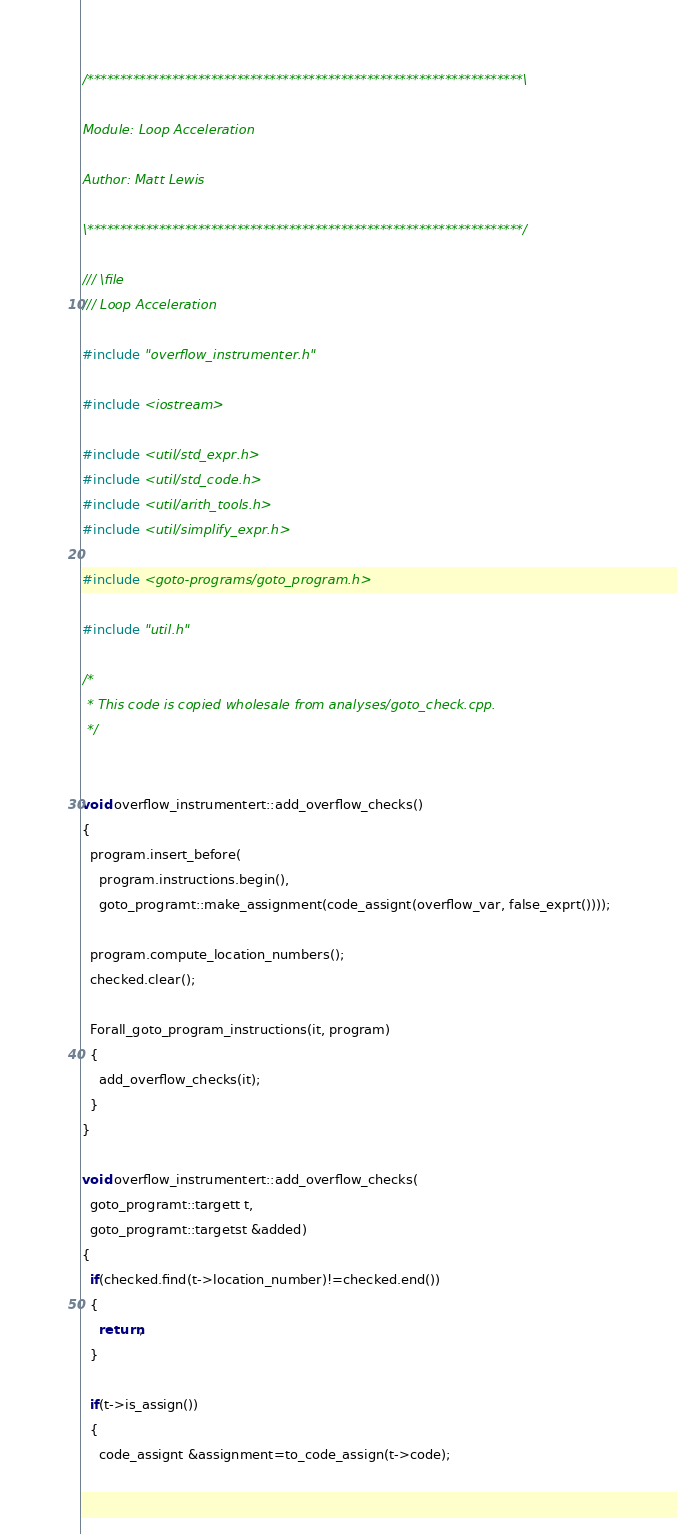<code> <loc_0><loc_0><loc_500><loc_500><_C++_>/*******************************************************************\

Module: Loop Acceleration

Author: Matt Lewis

\*******************************************************************/

/// \file
/// Loop Acceleration

#include "overflow_instrumenter.h"

#include <iostream>

#include <util/std_expr.h>
#include <util/std_code.h>
#include <util/arith_tools.h>
#include <util/simplify_expr.h>

#include <goto-programs/goto_program.h>

#include "util.h"

/*
 * This code is copied wholesale from analyses/goto_check.cpp.
 */


void overflow_instrumentert::add_overflow_checks()
{
  program.insert_before(
    program.instructions.begin(),
    goto_programt::make_assignment(code_assignt(overflow_var, false_exprt())));

  program.compute_location_numbers();
  checked.clear();

  Forall_goto_program_instructions(it, program)
  {
    add_overflow_checks(it);
  }
}

void overflow_instrumentert::add_overflow_checks(
  goto_programt::targett t,
  goto_programt::targetst &added)
{
  if(checked.find(t->location_number)!=checked.end())
  {
    return;
  }

  if(t->is_assign())
  {
    code_assignt &assignment=to_code_assign(t->code);
</code> 